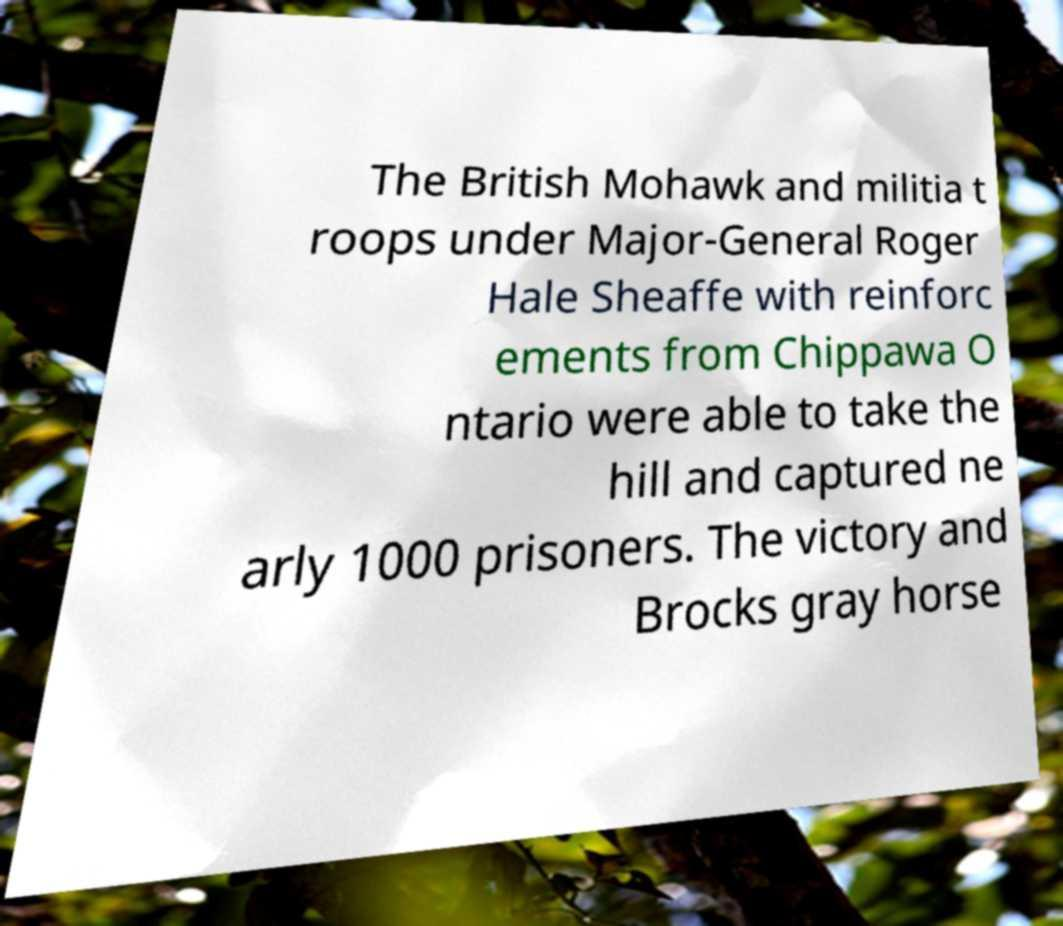Can you accurately transcribe the text from the provided image for me? The British Mohawk and militia t roops under Major-General Roger Hale Sheaffe with reinforc ements from Chippawa O ntario were able to take the hill and captured ne arly 1000 prisoners. The victory and Brocks gray horse 